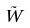Convert formula to latex. <formula><loc_0><loc_0><loc_500><loc_500>\tilde { W }</formula> 